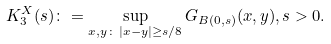<formula> <loc_0><loc_0><loc_500><loc_500>K ^ { X } _ { 3 } ( s ) \colon = \sup _ { x , y \colon \, | x - y | \geq s / 8 } G _ { B ( 0 , s ) } ( x , y ) , s > 0 .</formula> 